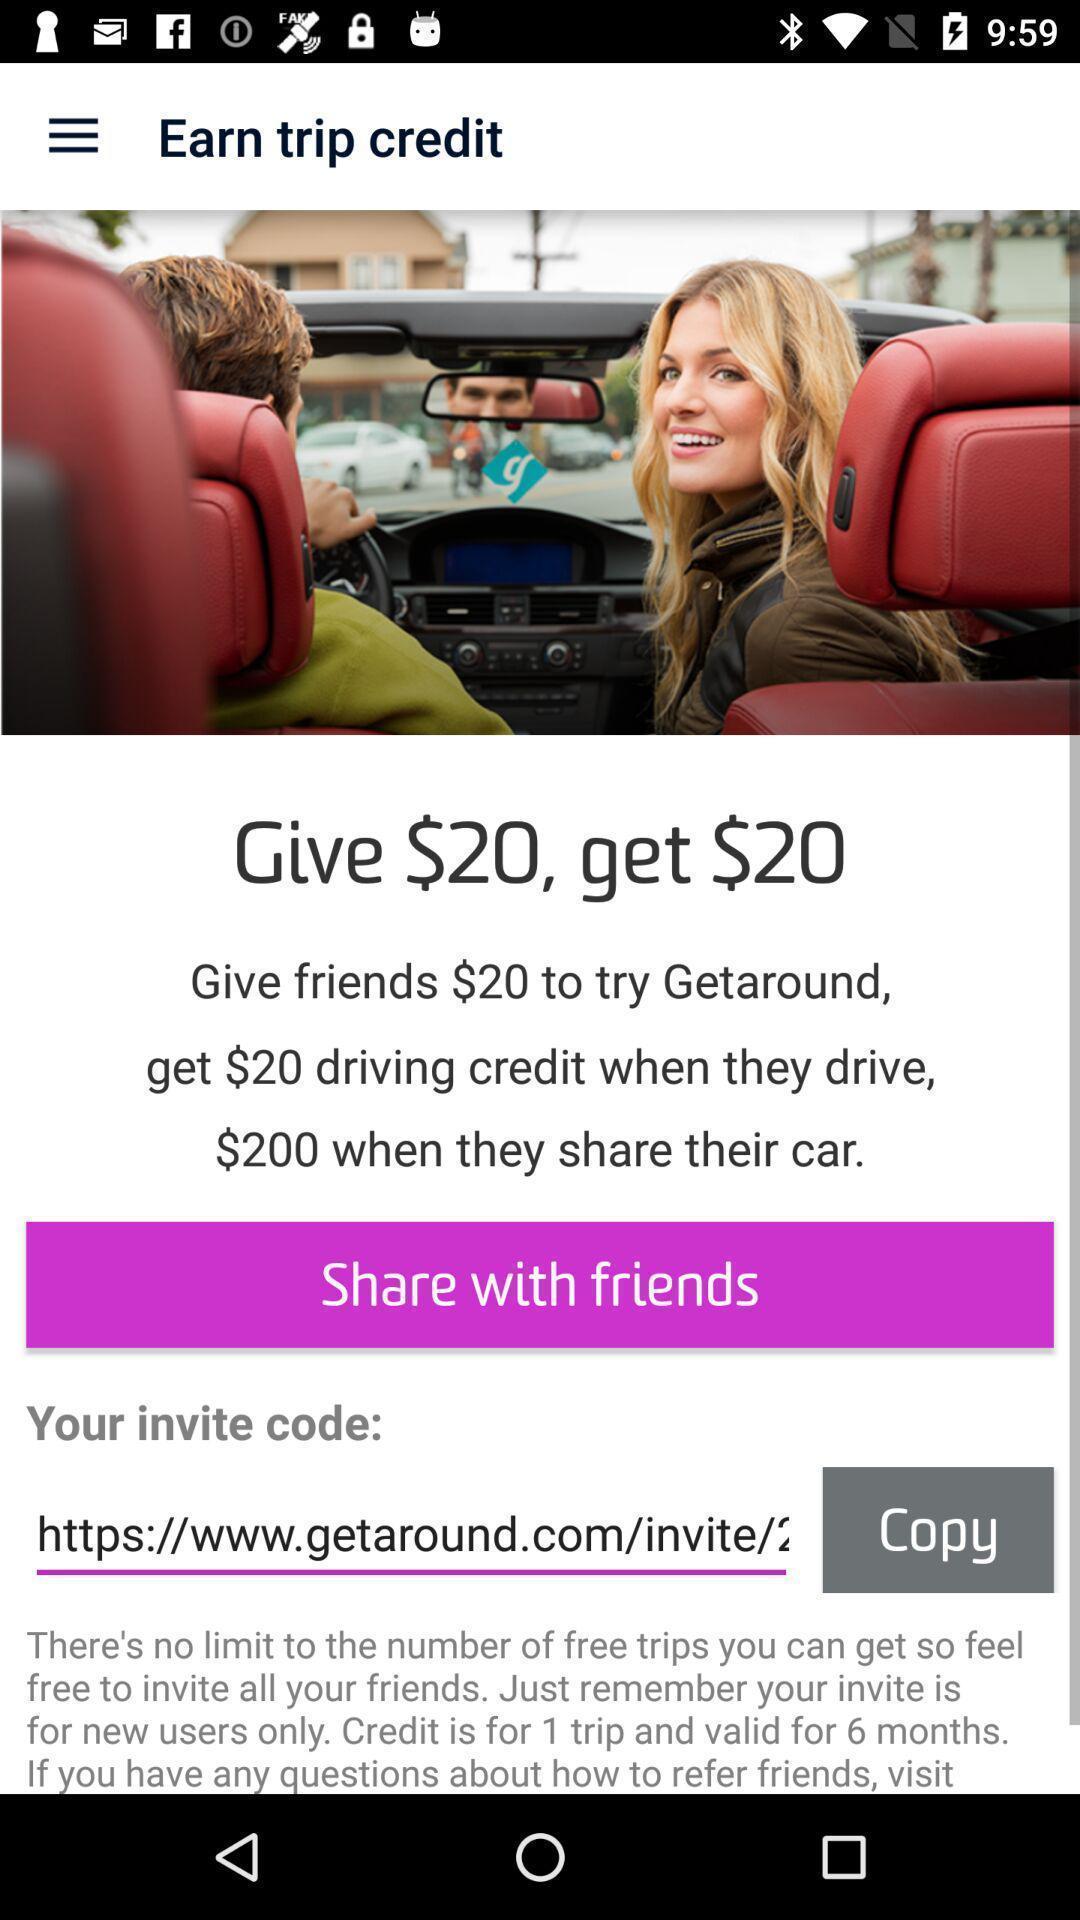Provide a detailed account of this screenshot. Share with friends of earn trip credits. 